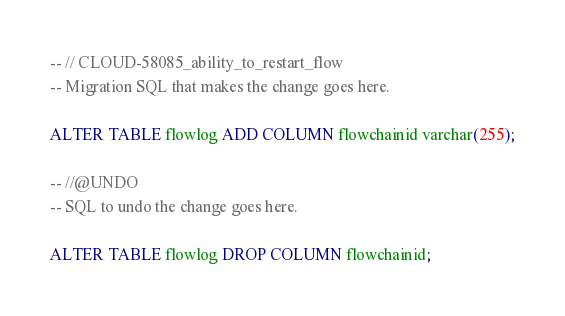Convert code to text. <code><loc_0><loc_0><loc_500><loc_500><_SQL_>-- // CLOUD-58085_ability_to_restart_flow
-- Migration SQL that makes the change goes here.

ALTER TABLE flowlog ADD COLUMN flowchainid varchar(255);

-- //@UNDO
-- SQL to undo the change goes here.

ALTER TABLE flowlog DROP COLUMN flowchainid;</code> 